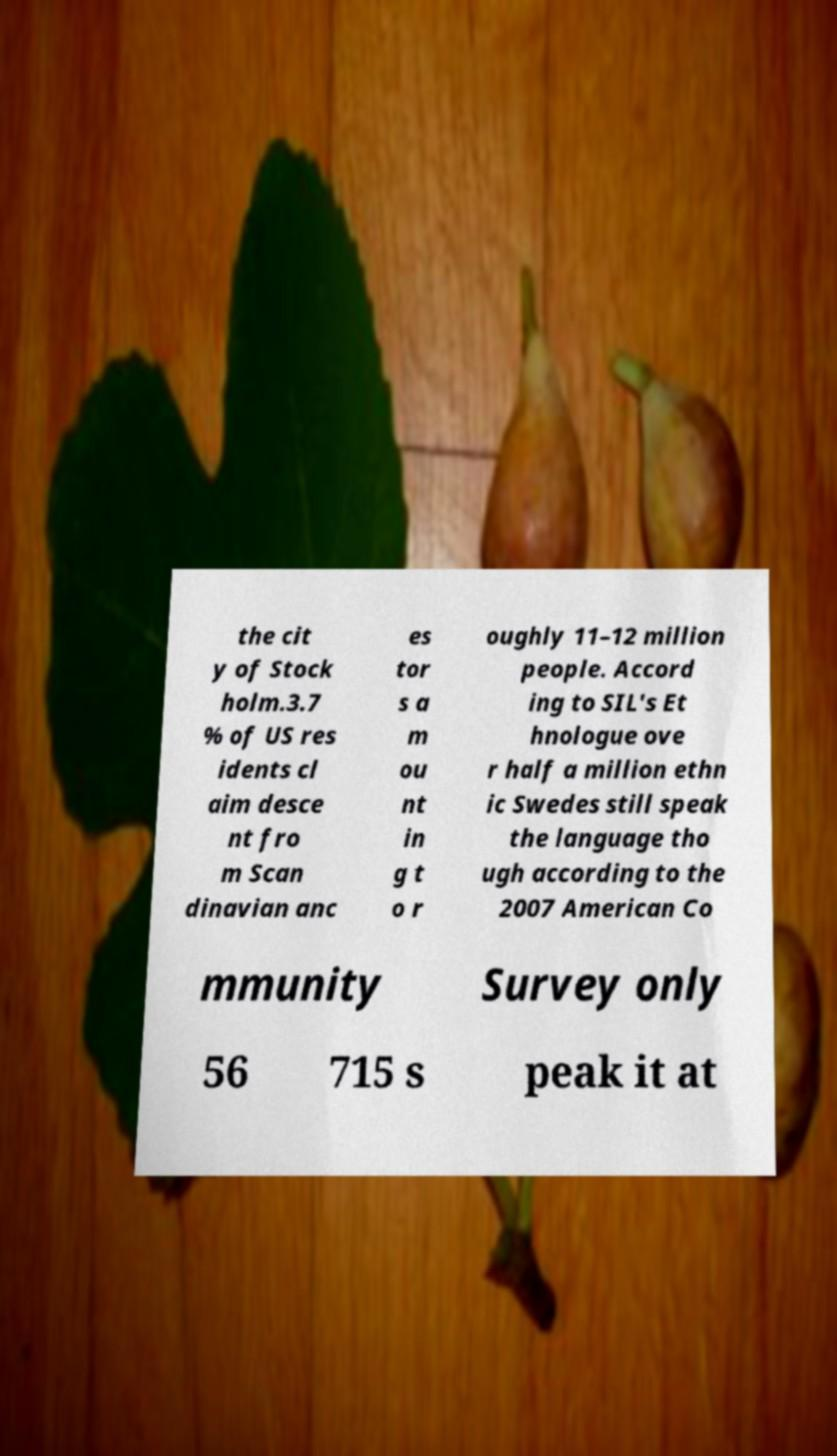There's text embedded in this image that I need extracted. Can you transcribe it verbatim? the cit y of Stock holm.3.7 % of US res idents cl aim desce nt fro m Scan dinavian anc es tor s a m ou nt in g t o r oughly 11–12 million people. Accord ing to SIL's Et hnologue ove r half a million ethn ic Swedes still speak the language tho ugh according to the 2007 American Co mmunity Survey only 56 715 s peak it at 